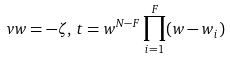Convert formula to latex. <formula><loc_0><loc_0><loc_500><loc_500>v w = - \zeta , \, t = w ^ { N - F } \prod _ { i = 1 } ^ { F } ( w - w _ { i } )</formula> 